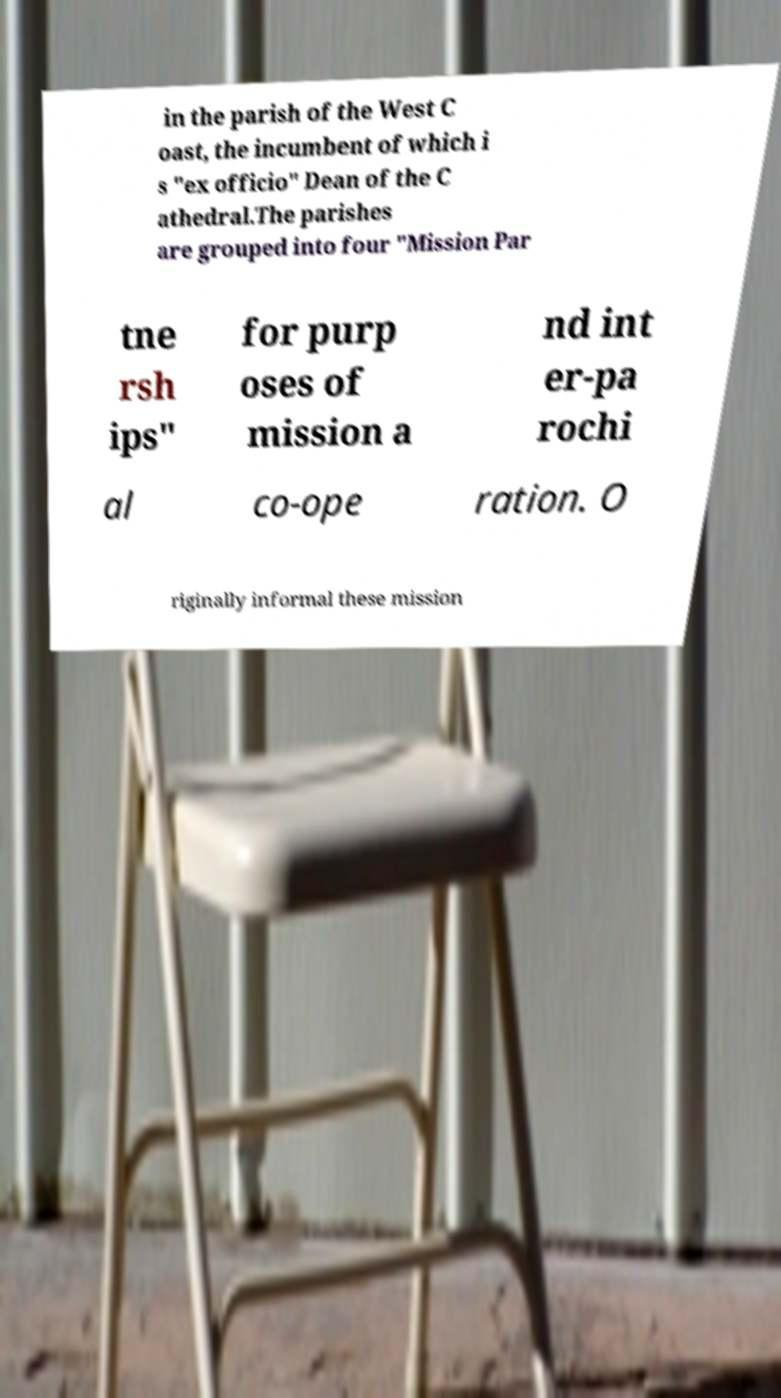Please read and relay the text visible in this image. What does it say? in the parish of the West C oast, the incumbent of which i s "ex officio" Dean of the C athedral.The parishes are grouped into four "Mission Par tne rsh ips" for purp oses of mission a nd int er-pa rochi al co-ope ration. O riginally informal these mission 